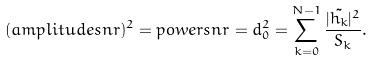Convert formula to latex. <formula><loc_0><loc_0><loc_500><loc_500>( a m p l i t u d e s n r ) ^ { 2 } = p o w e r s n r = d _ { 0 } ^ { 2 } = \sum _ { k = 0 } ^ { N - 1 } \frac { | \tilde { h _ { k } } | ^ { 2 } } { S _ { k } } .</formula> 